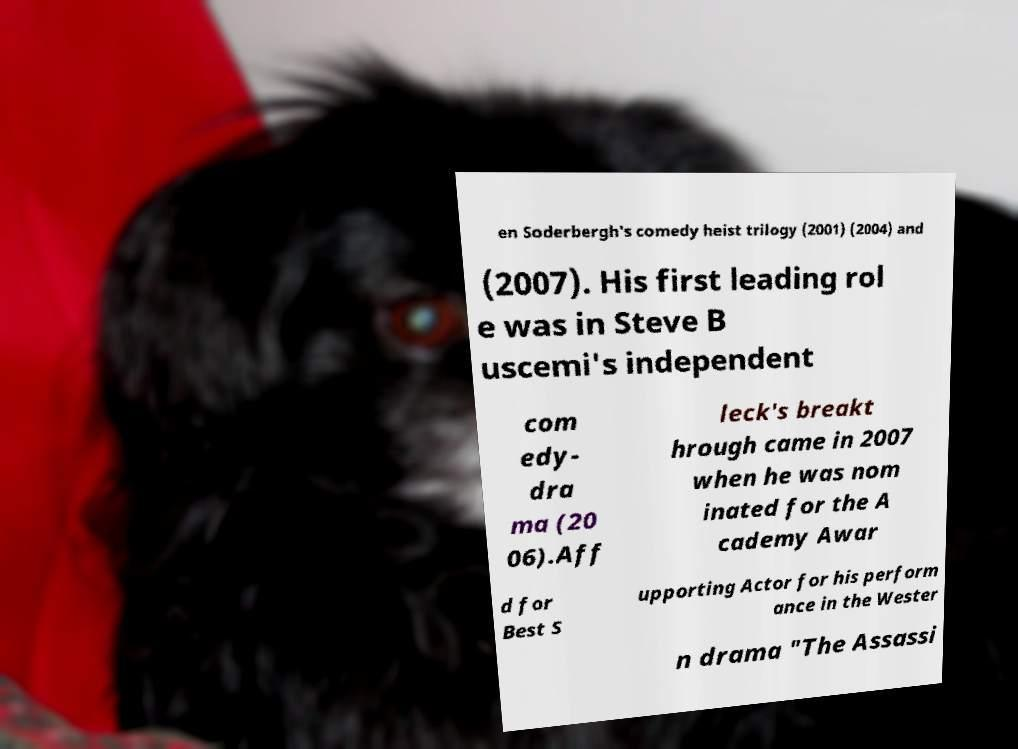Could you assist in decoding the text presented in this image and type it out clearly? en Soderbergh's comedy heist trilogy (2001) (2004) and (2007). His first leading rol e was in Steve B uscemi's independent com edy- dra ma (20 06).Aff leck's breakt hrough came in 2007 when he was nom inated for the A cademy Awar d for Best S upporting Actor for his perform ance in the Wester n drama "The Assassi 